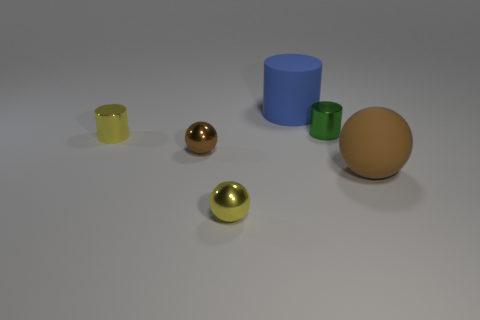The matte ball is what color?
Your response must be concise. Brown. There is a cylinder that is in front of the tiny shiny cylinder right of the small metal cylinder that is on the left side of the brown metal sphere; what is its material?
Make the answer very short. Metal. What is the size of the yellow sphere that is made of the same material as the small green cylinder?
Your answer should be compact. Small. Is there a large matte object that has the same color as the rubber ball?
Provide a short and direct response. No. There is a brown metallic thing; does it have the same size as the metallic cylinder to the left of the large blue cylinder?
Make the answer very short. Yes. How many large cylinders are left of the yellow metallic thing behind the tiny sphere that is in front of the big brown rubber sphere?
Offer a terse response. 0. There is a object that is the same color as the matte ball; what is its size?
Provide a short and direct response. Small. Are there any small yellow metal things left of the yellow metallic cylinder?
Make the answer very short. No. The brown rubber thing is what shape?
Offer a terse response. Sphere. The matte thing that is to the left of the small shiny cylinder that is on the right side of the brown sphere to the left of the tiny yellow ball is what shape?
Offer a very short reply. Cylinder. 